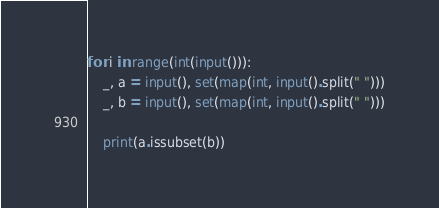Convert code to text. <code><loc_0><loc_0><loc_500><loc_500><_Python_>for i in range(int(input())):
    _, a = input(), set(map(int, input().split(" ")))
    _, b = input(), set(map(int, input().split(" ")))

    print(a.issubset(b))</code> 